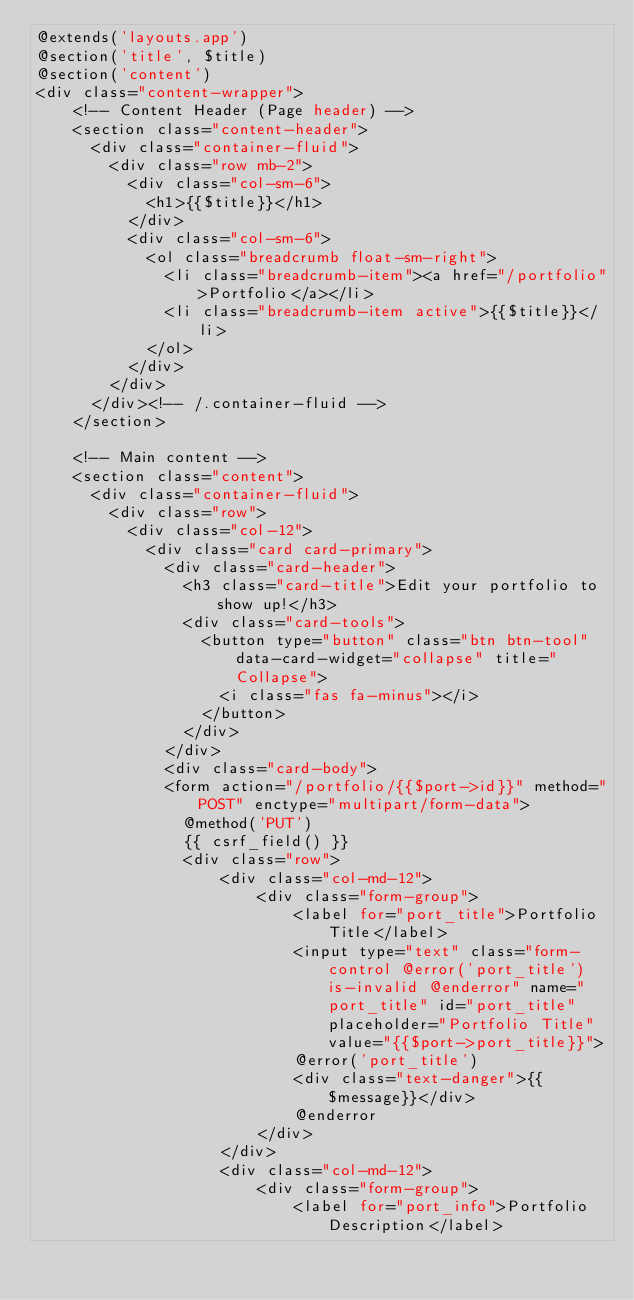Convert code to text. <code><loc_0><loc_0><loc_500><loc_500><_PHP_>@extends('layouts.app')
@section('title', $title)
@section('content')
<div class="content-wrapper">
    <!-- Content Header (Page header) -->
    <section class="content-header">
      <div class="container-fluid">
        <div class="row mb-2">
          <div class="col-sm-6">
            <h1>{{$title}}</h1>
          </div>
          <div class="col-sm-6">
            <ol class="breadcrumb float-sm-right">
              <li class="breadcrumb-item"><a href="/portfolio">Portfolio</a></li>
              <li class="breadcrumb-item active">{{$title}}</li>
            </ol>
          </div>
        </div>
      </div><!-- /.container-fluid -->
    </section>

    <!-- Main content -->
    <section class="content">
      <div class="container-fluid">
        <div class="row">
          <div class="col-12">
            <div class="card card-primary">
              <div class="card-header">
                <h3 class="card-title">Edit your portfolio to show up!</h3>
                <div class="card-tools">
                  <button type="button" class="btn btn-tool" data-card-widget="collapse" title="Collapse">
                    <i class="fas fa-minus"></i>
                  </button>
                </div>
              </div> 
              <div class="card-body">
              <form action="/portfolio/{{$port->id}}" method="POST" enctype="multipart/form-data">
                @method('PUT')
                {{ csrf_field() }}
                <div class="row">
                    <div class="col-md-12">
                        <div class="form-group">
                            <label for="port_title">Portfolio Title</label>
                            <input type="text" class="form-control @error('port_title') is-invalid @enderror" name="port_title" id="port_title" placeholder="Portfolio Title" value="{{$port->port_title}}">
                            @error('port_title')
                            <div class="text-danger">{{$message}}</div>
                            @enderror
                        </div>
                    </div>
                    <div class="col-md-12">
                        <div class="form-group">
                            <label for="port_info">Portfolio Description</label></code> 